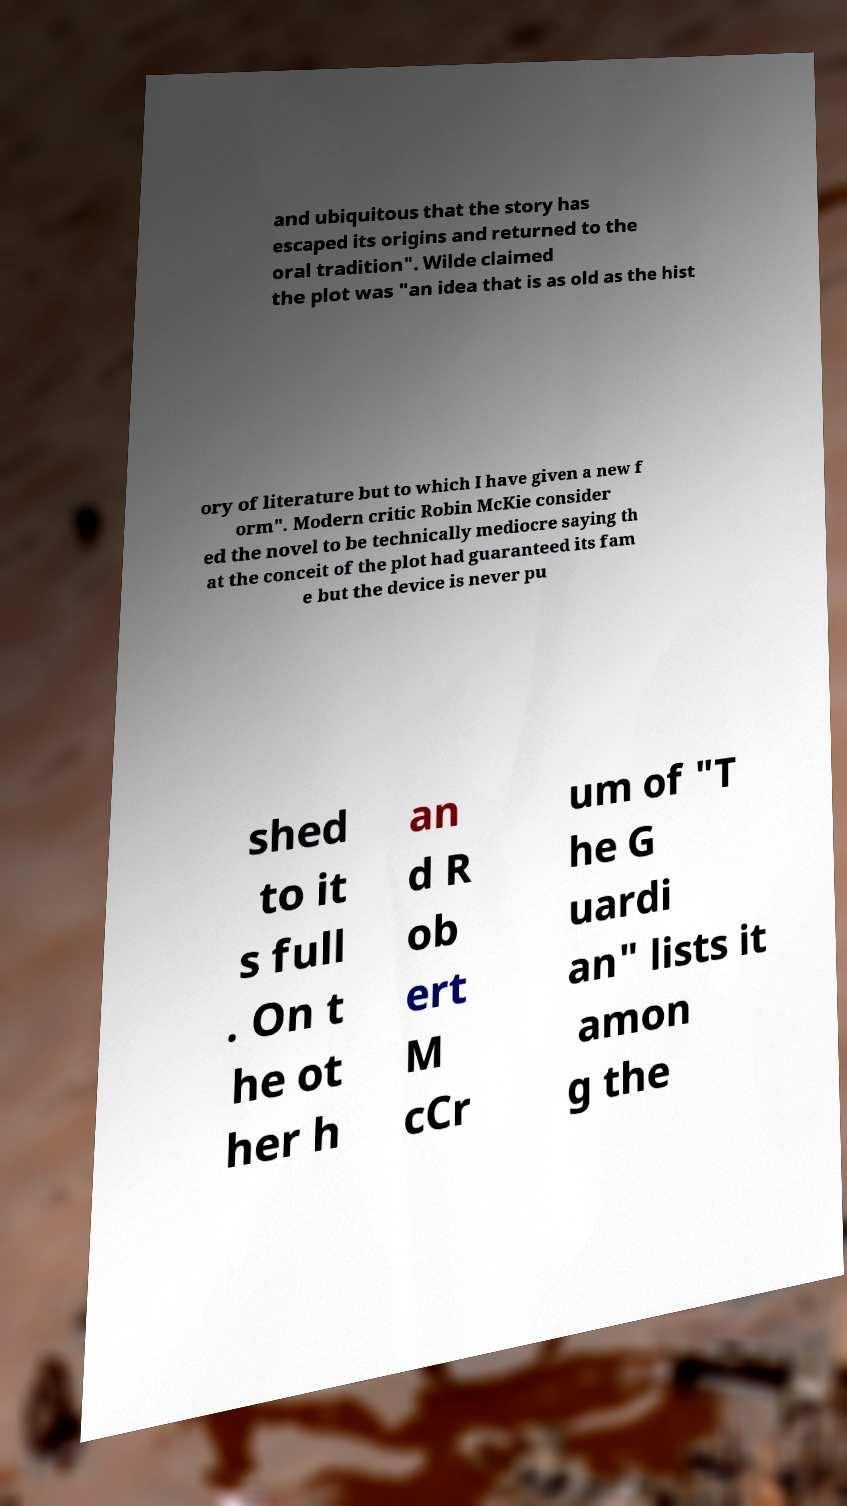Can you accurately transcribe the text from the provided image for me? and ubiquitous that the story has escaped its origins and returned to the oral tradition". Wilde claimed the plot was "an idea that is as old as the hist ory of literature but to which I have given a new f orm". Modern critic Robin McKie consider ed the novel to be technically mediocre saying th at the conceit of the plot had guaranteed its fam e but the device is never pu shed to it s full . On t he ot her h an d R ob ert M cCr um of "T he G uardi an" lists it amon g the 